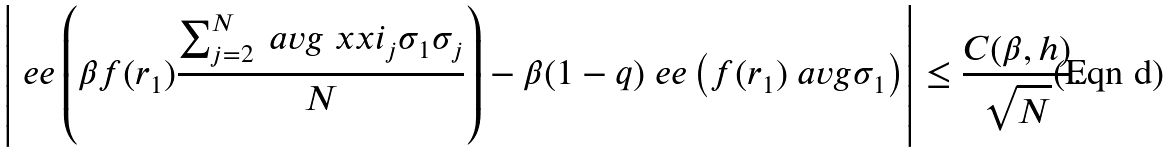<formula> <loc_0><loc_0><loc_500><loc_500>\left | \ e e \left ( \beta f ( r _ { 1 } ) \frac { \sum _ { j = 2 } ^ { N } \ a v g { \ x x i _ { j } \sigma _ { 1 } \sigma _ { j } } } { N } \right ) - \beta ( 1 - q ) \ e e \left ( f ( r _ { 1 } ) \ a v g { \sigma _ { 1 } } \right ) \right | \leq \frac { C ( \beta , h ) } { \sqrt { N } } .</formula> 